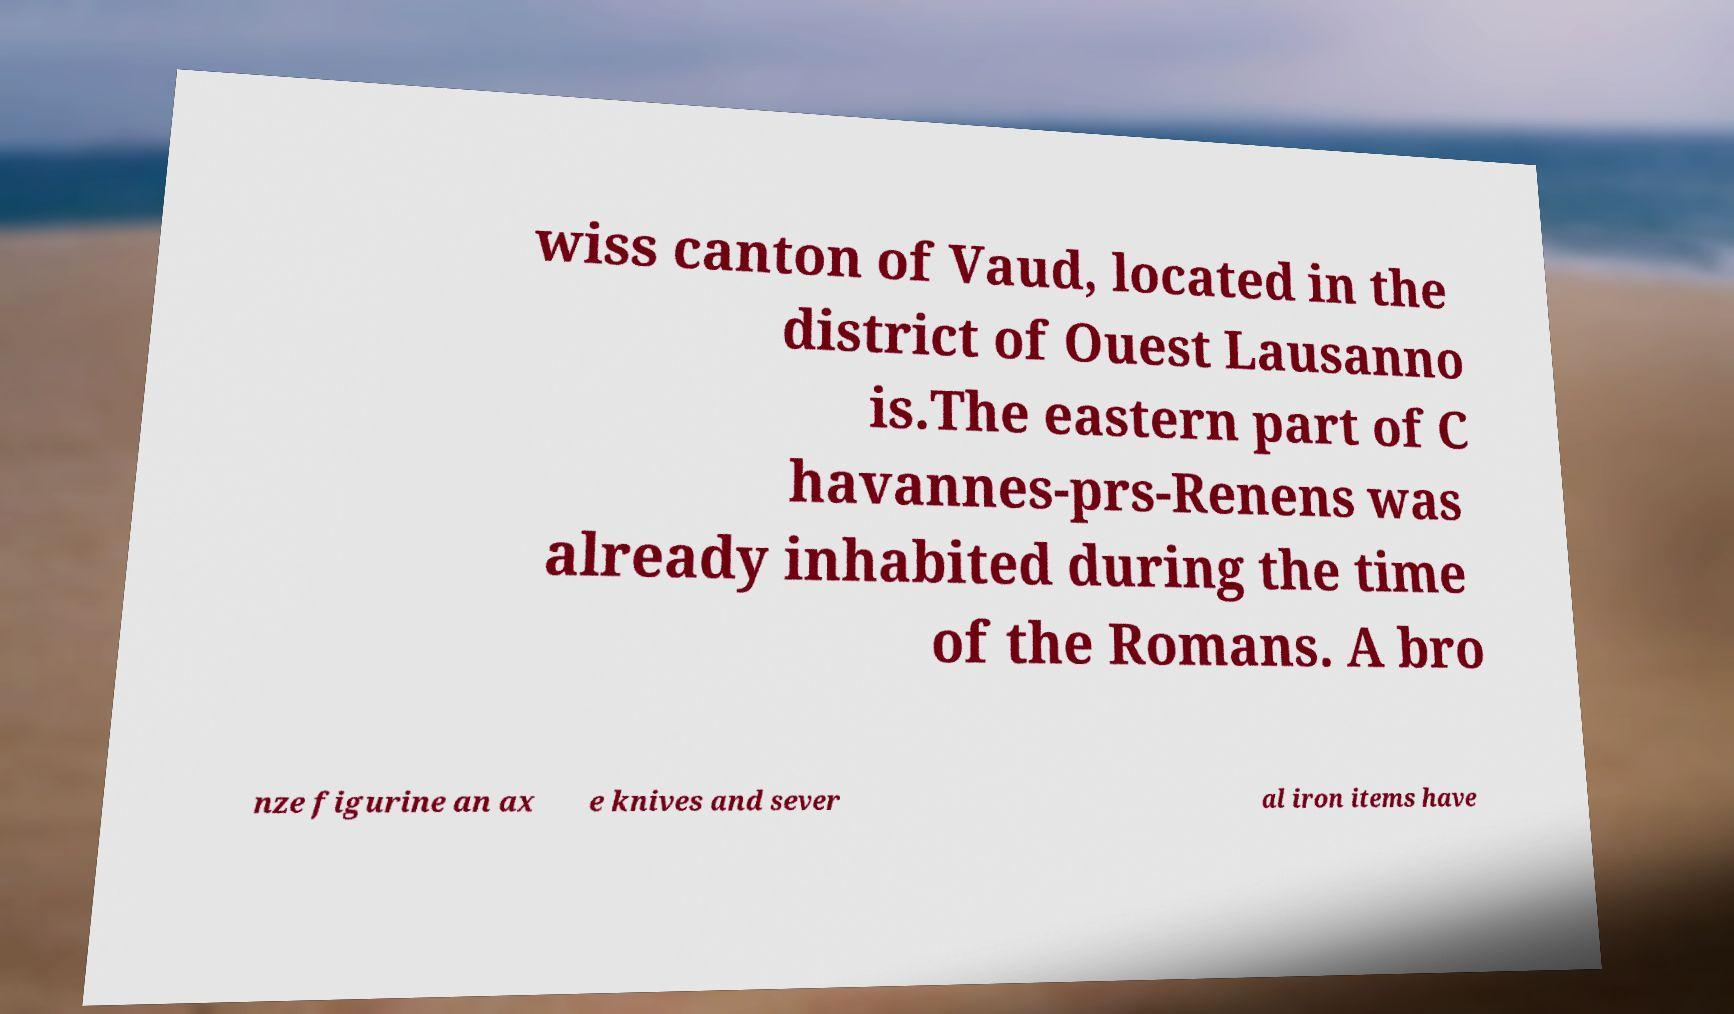Can you accurately transcribe the text from the provided image for me? wiss canton of Vaud, located in the district of Ouest Lausanno is.The eastern part of C havannes-prs-Renens was already inhabited during the time of the Romans. A bro nze figurine an ax e knives and sever al iron items have 